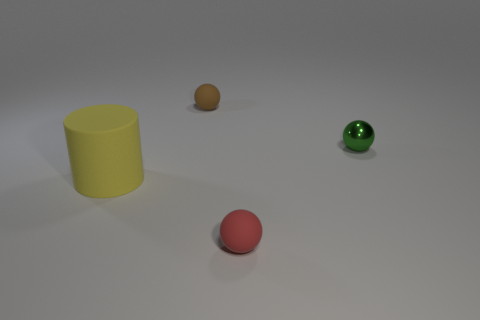Add 3 yellow things. How many objects exist? 7 Subtract all spheres. How many objects are left? 1 Subtract all big yellow cylinders. Subtract all small green rubber cylinders. How many objects are left? 3 Add 1 tiny brown matte things. How many tiny brown matte things are left? 2 Add 3 red things. How many red things exist? 4 Subtract 0 cyan blocks. How many objects are left? 4 